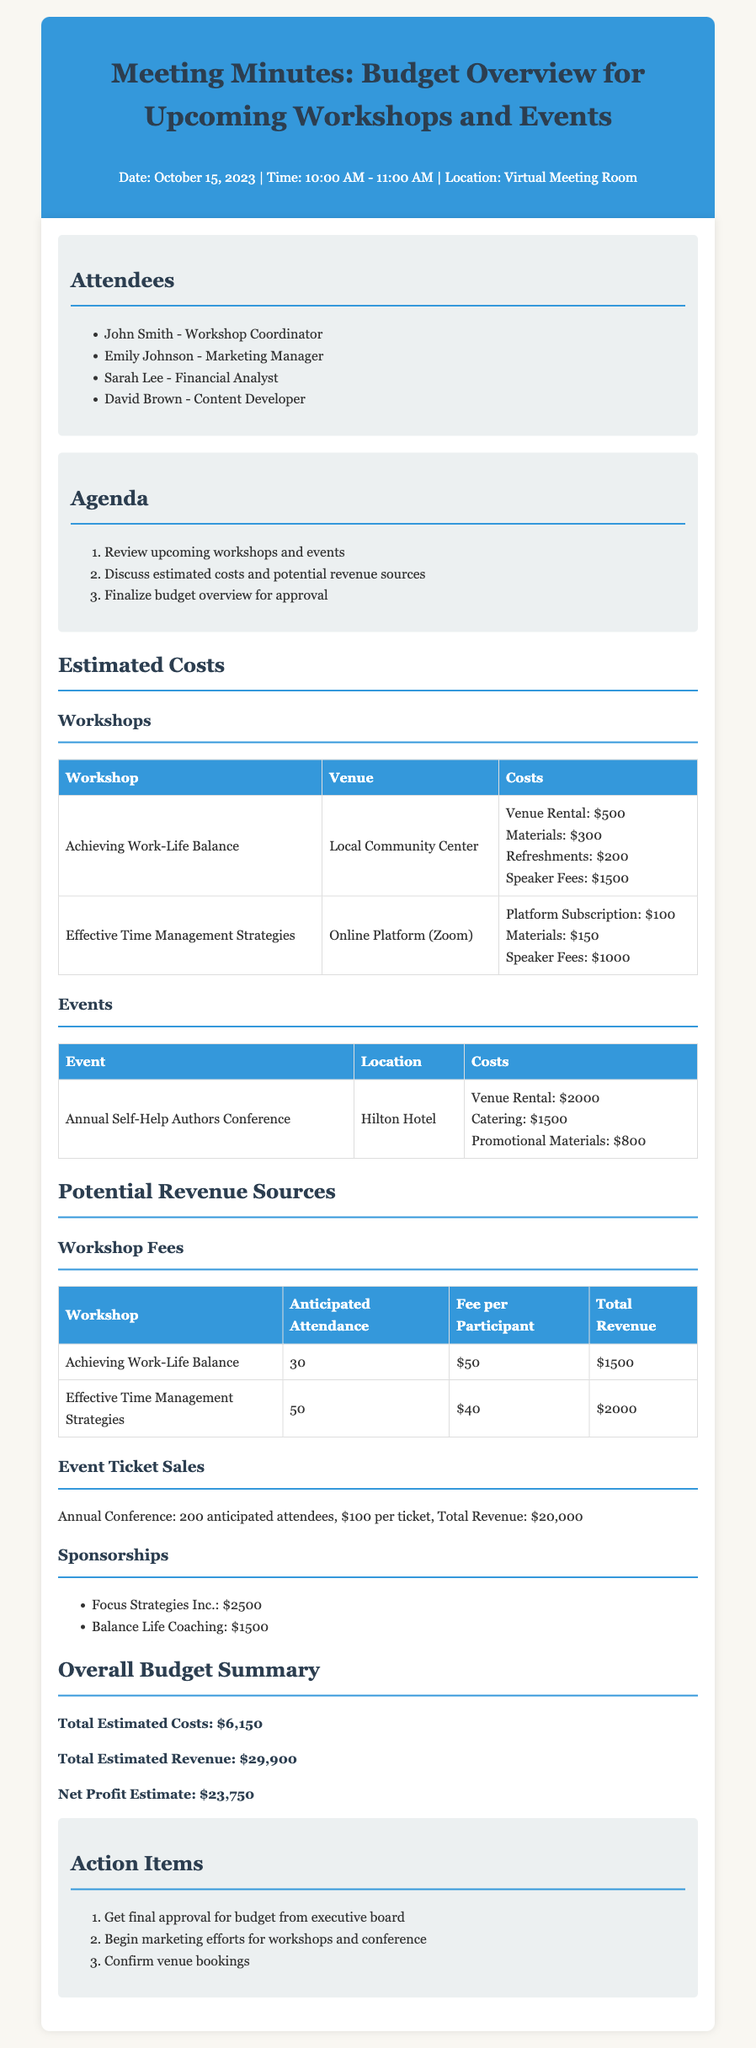what is the date of the meeting? The date of the meeting is stated at the top of the document as October 15, 2023.
Answer: October 15, 2023 who is the Workshop Coordinator? The document lists John Smith as the Workshop Coordinator under the attendees section.
Answer: John Smith what are the total estimated costs for workshops? The total estimated costs for workshops can be found by summing the costs of individual workshops provided in the table.
Answer: $2,500 how many anticipated attendees are expected for the Annual Self-Help Authors Conference? The document specifies that there are 200 anticipated attendees for the annual conference under the event ticket sales section.
Answer: 200 what is the total estimated revenue from workshops? The revenue from workshops is calculated by adding the total revenue from both workshops listed in the document.
Answer: $3,500 what is the total estimated revenue for the Annual Self-Help Authors Conference? The document provides a total revenue figure for the conference as $20,000.
Answer: $20,000 how much sponsorship is provided by Balance Life Coaching? The document lists the sponsorship amount for Balance Life Coaching under the sponsorships section.
Answer: $1,500 what is the net profit estimate from the overall budget? The net profit estimate is given as the difference between total estimated revenue and total estimated costs summarized in the overall budget section.
Answer: $23,750 what action item involves marketing efforts? The document states that "Begin marketing efforts for workshops and conference" as an action item.
Answer: Begin marketing efforts for workshops and conference 